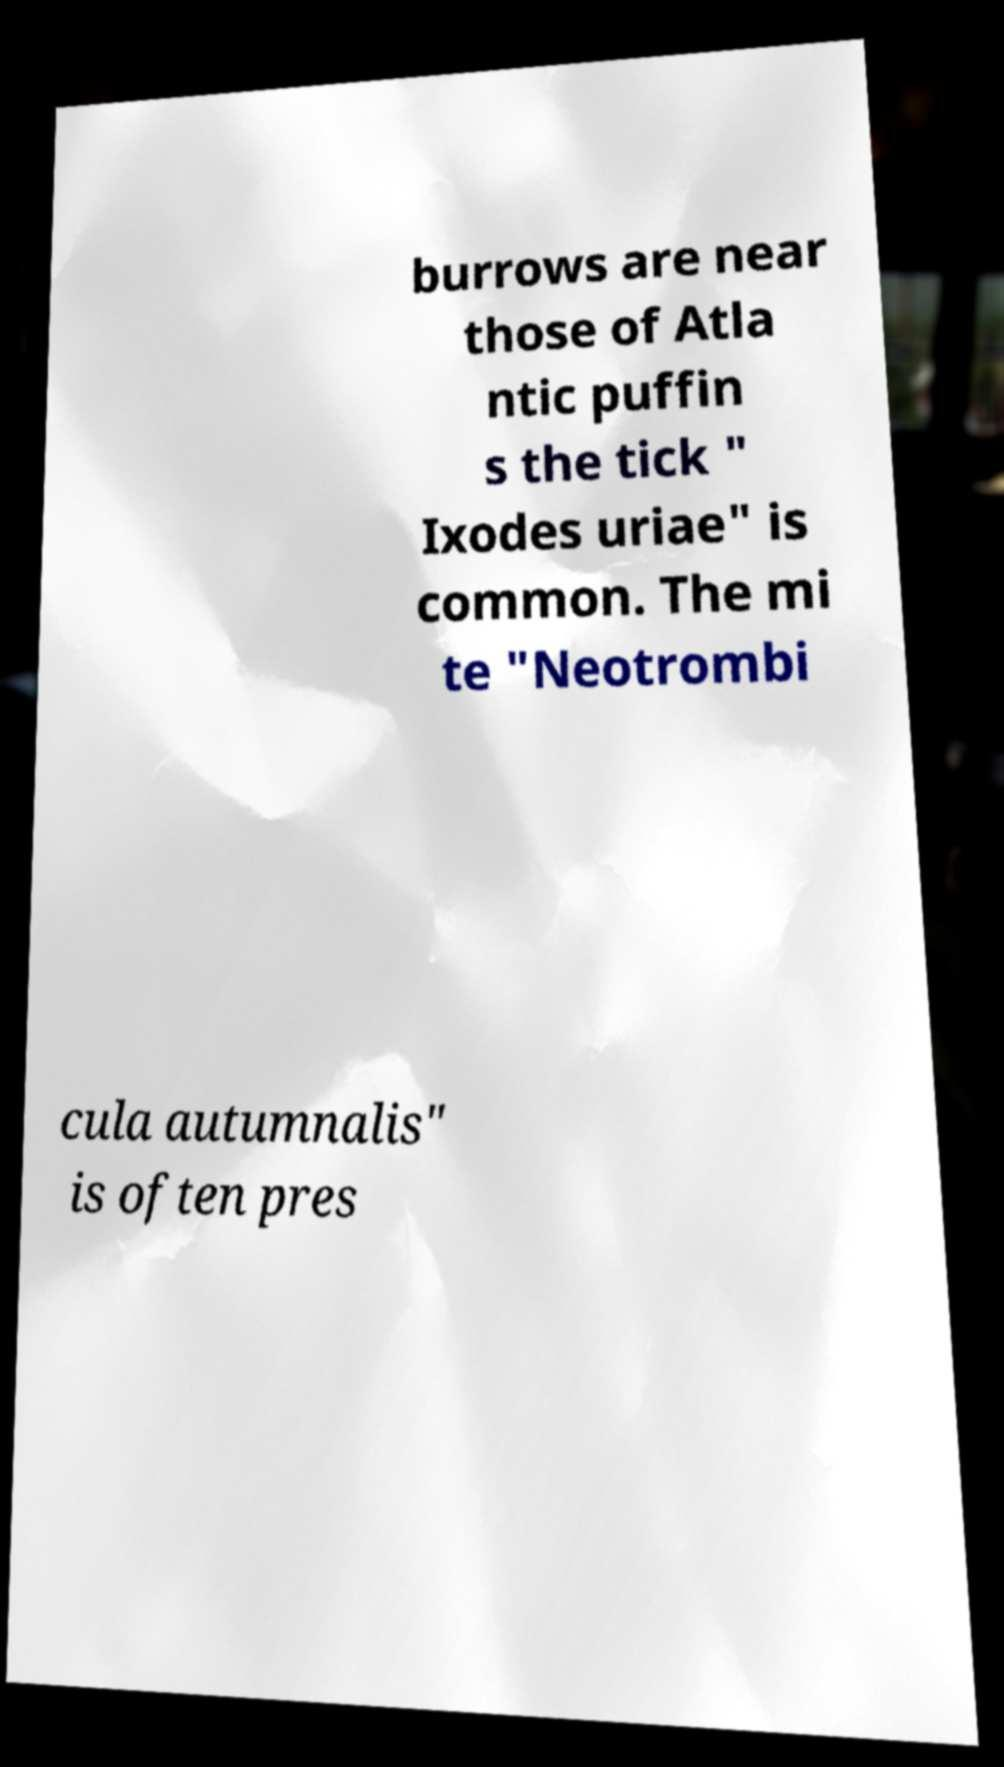Can you read and provide the text displayed in the image?This photo seems to have some interesting text. Can you extract and type it out for me? burrows are near those of Atla ntic puffin s the tick " Ixodes uriae" is common. The mi te "Neotrombi cula autumnalis" is often pres 